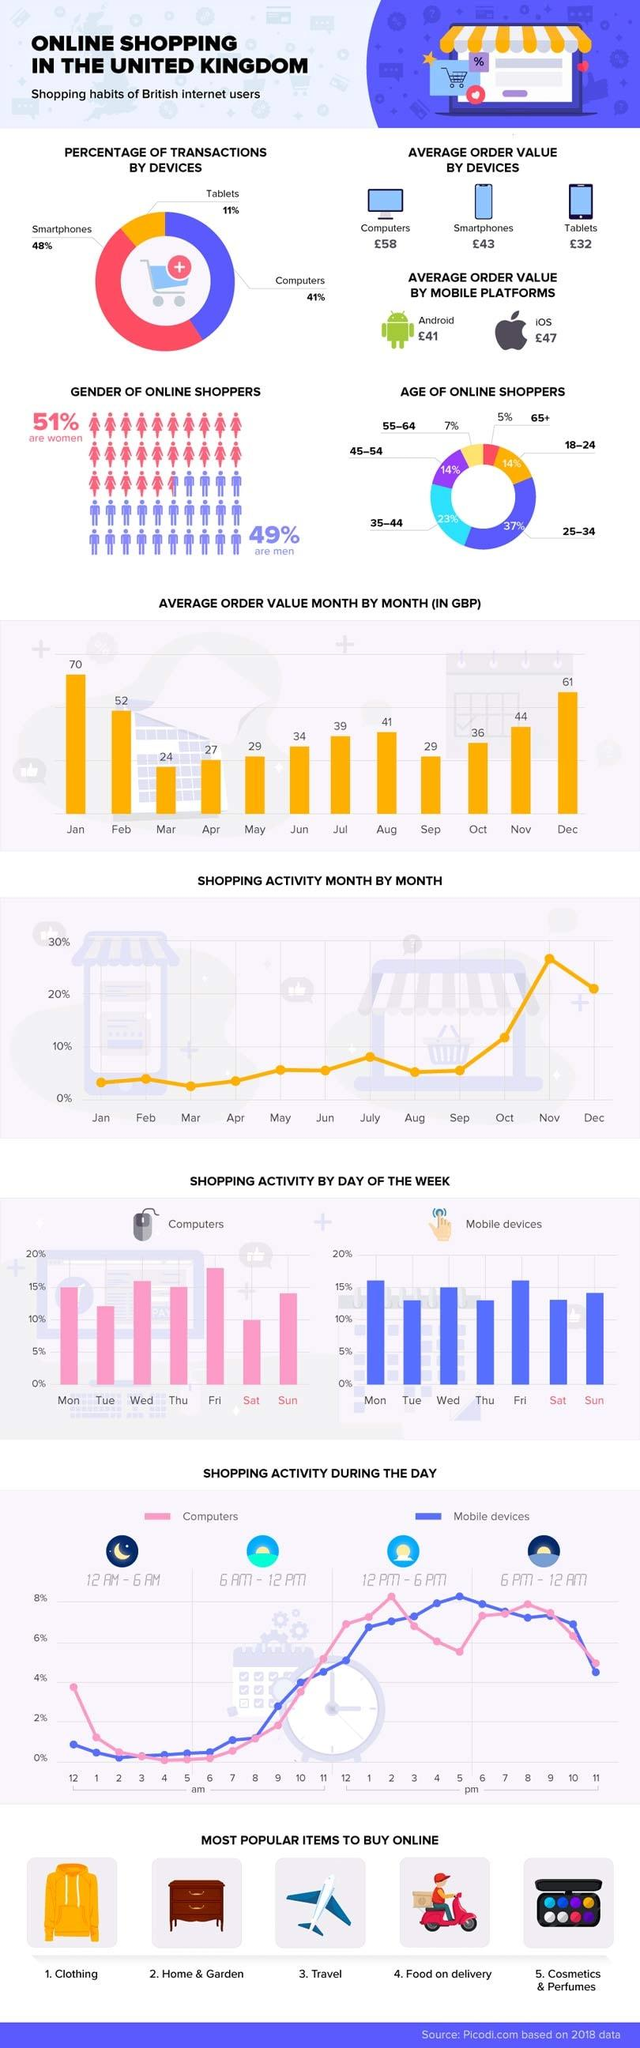Outline some significant characteristics in this image. In 2018, the average order value of online shopping done through tablets in the UK was approximately £32. In 2018, smartphones were the most commonly used devices by UK people for online transactions. In 2018, 37% of online shoppers in the UK fell within the age group of 25-34. The average order value of online shopping done through iOS phones in the UK in 2018 was £47. In 2018, approximately 41% of online transactions in the UK were completed through computers, according to data available. 